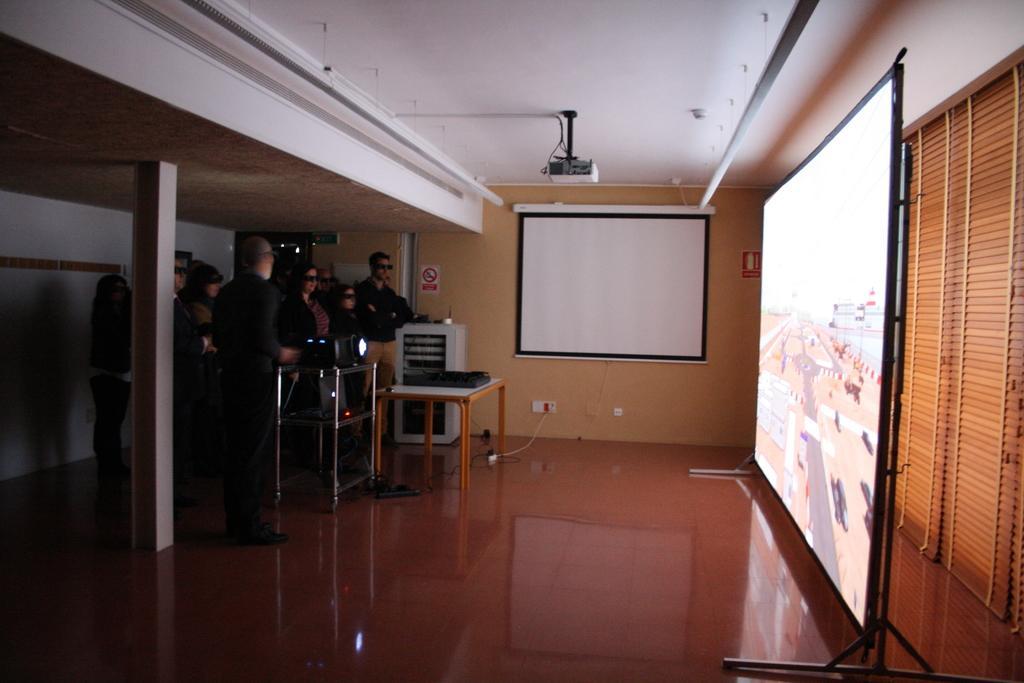How would you summarize this image in a sentence or two? On the right side there is a screen. Also there are curtains. In the back there is a wall. On the wall there is a whiteboard. On the ceiling there is a projector. On the left side there is a pillar. Also there are many people standing and wearing goggles. There is a table. On that there is a projector. There is another table. 